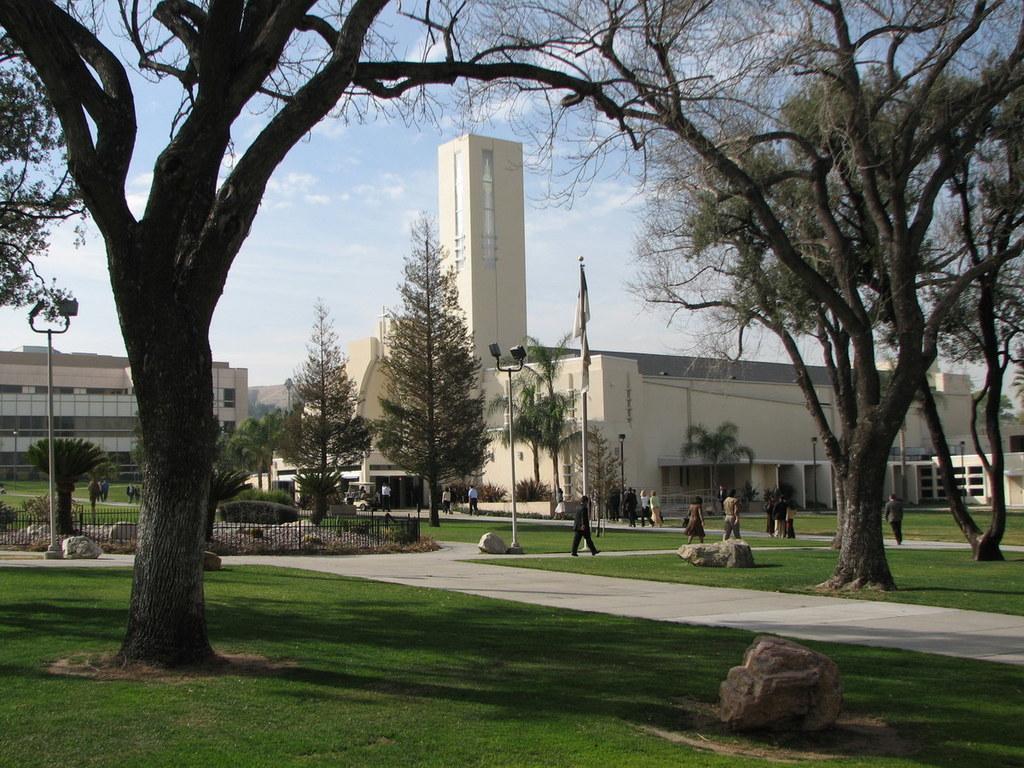Describe this image in one or two sentences. In this image, we can see people on the ground and there are rocks. In the background, we can see trees, lights, poles, buildings, railings and we can see a flag. At the top, there are clouds in the sky. 